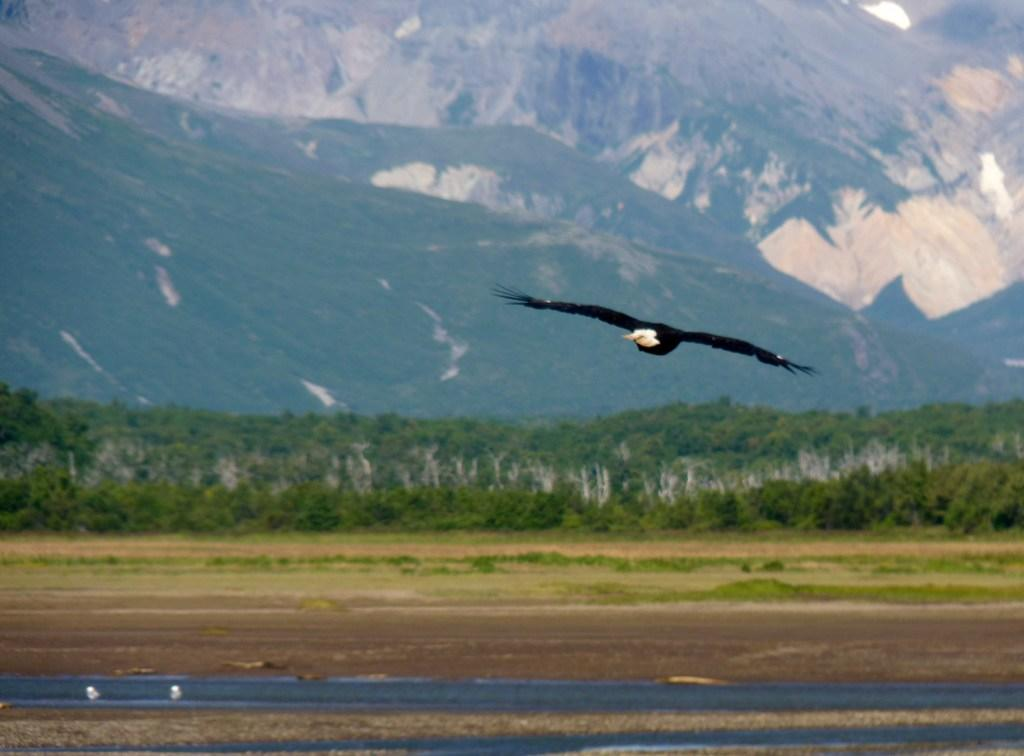What animal is the main subject of the image? There is an eagle in the image. Where is the eagle located in the image? The eagle is in the middle of the image. What can be seen in the background of the image? There are trees and mountains in the background of the image. What type of fork can be seen in the image? There is no fork present in the image; it features an eagle in the middle of the image with trees and mountains in the background. What is the eagle's interest in the canvas in the image? There is no canvas present in the image, and therefore no interest can be attributed to the eagle. 